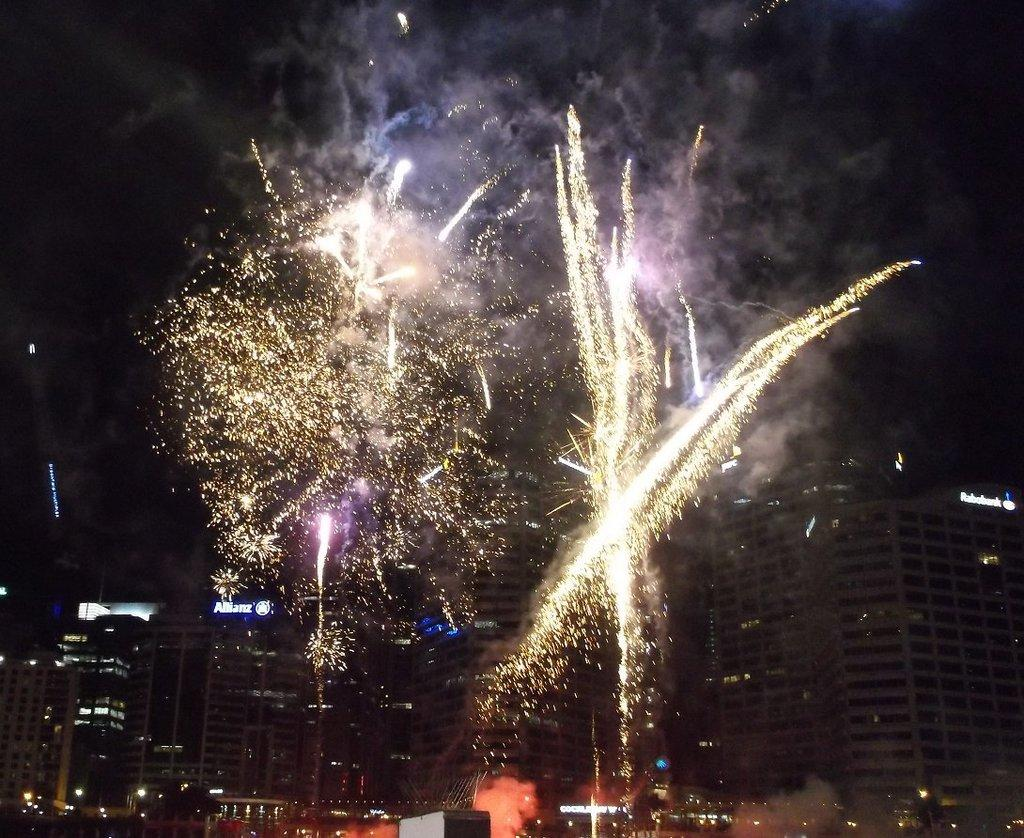What type of structures are present in the image? There are buildings in the image. What feature can be seen on the buildings? There are windows visible on the buildings. What type of food item is present in the image? There are crackers in the image. What is the nature of the smoke in the image? There is smoke in the image. What part of the natural environment is visible in the image? The sky is visible in the image. How is the hose being used to put out the ice in the image? There is no ice or hose present in the image. 